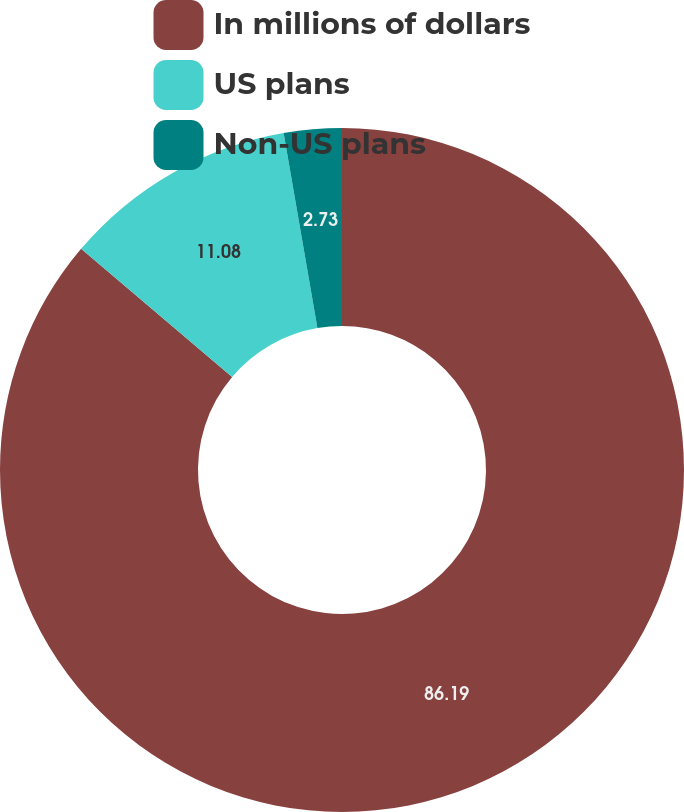Convert chart to OTSL. <chart><loc_0><loc_0><loc_500><loc_500><pie_chart><fcel>In millions of dollars<fcel>US plans<fcel>Non-US plans<nl><fcel>86.19%<fcel>11.08%<fcel>2.73%<nl></chart> 